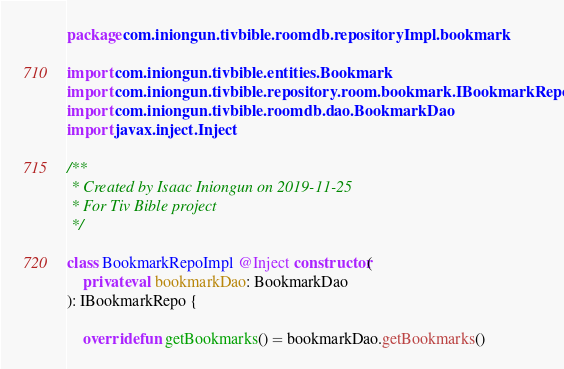Convert code to text. <code><loc_0><loc_0><loc_500><loc_500><_Kotlin_>package com.iniongun.tivbible.roomdb.repositoryImpl.bookmark

import com.iniongun.tivbible.entities.Bookmark
import com.iniongun.tivbible.repository.room.bookmark.IBookmarkRepo
import com.iniongun.tivbible.roomdb.dao.BookmarkDao
import javax.inject.Inject

/**
 * Created by Isaac Iniongun on 2019-11-25
 * For Tiv Bible project
 */

class BookmarkRepoImpl @Inject constructor(
    private val bookmarkDao: BookmarkDao
): IBookmarkRepo {

    override fun getBookmarks() = bookmarkDao.getBookmarks()
</code> 